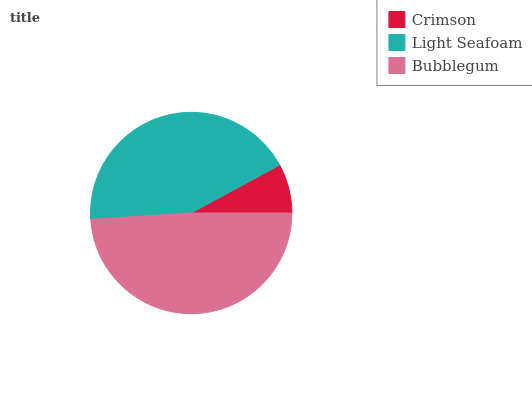Is Crimson the minimum?
Answer yes or no. Yes. Is Bubblegum the maximum?
Answer yes or no. Yes. Is Light Seafoam the minimum?
Answer yes or no. No. Is Light Seafoam the maximum?
Answer yes or no. No. Is Light Seafoam greater than Crimson?
Answer yes or no. Yes. Is Crimson less than Light Seafoam?
Answer yes or no. Yes. Is Crimson greater than Light Seafoam?
Answer yes or no. No. Is Light Seafoam less than Crimson?
Answer yes or no. No. Is Light Seafoam the high median?
Answer yes or no. Yes. Is Light Seafoam the low median?
Answer yes or no. Yes. Is Bubblegum the high median?
Answer yes or no. No. Is Crimson the low median?
Answer yes or no. No. 